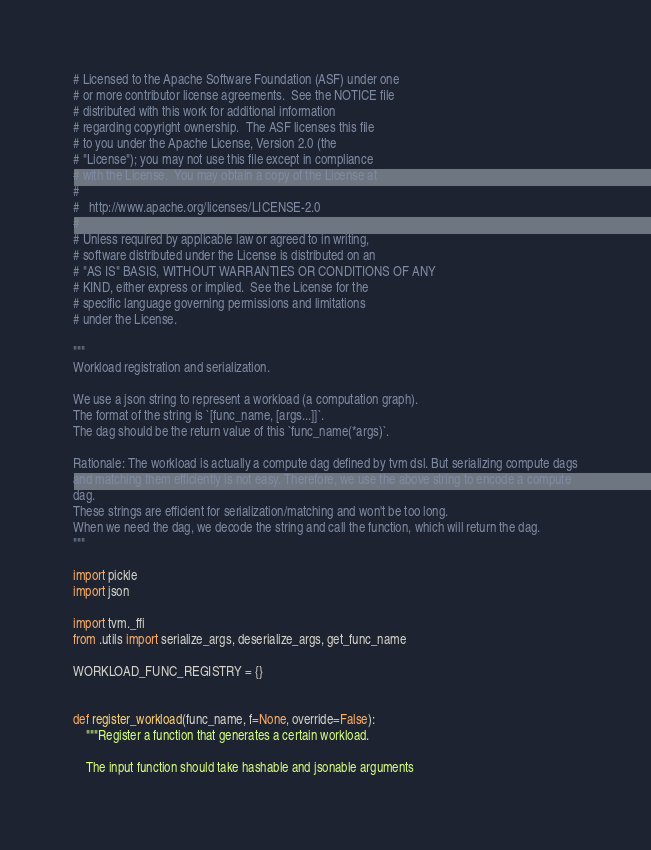Convert code to text. <code><loc_0><loc_0><loc_500><loc_500><_Python_># Licensed to the Apache Software Foundation (ASF) under one
# or more contributor license agreements.  See the NOTICE file
# distributed with this work for additional information
# regarding copyright ownership.  The ASF licenses this file
# to you under the Apache License, Version 2.0 (the
# "License"); you may not use this file except in compliance
# with the License.  You may obtain a copy of the License at
#
#   http://www.apache.org/licenses/LICENSE-2.0
#
# Unless required by applicable law or agreed to in writing,
# software distributed under the License is distributed on an
# "AS IS" BASIS, WITHOUT WARRANTIES OR CONDITIONS OF ANY
# KIND, either express or implied.  See the License for the
# specific language governing permissions and limitations
# under the License.

"""
Workload registration and serialization.

We use a json string to represent a workload (a computation graph).
The format of the string is `[func_name, [args...]]`.
The dag should be the return value of this `func_name(*args)`.

Rationale: The workload is actually a compute dag defined by tvm dsl. But serializing compute dags
and matching them efficiently is not easy. Therefore, we use the above string to encode a compute
dag.
These strings are efficient for serialization/matching and won't be too long.
When we need the dag, we decode the string and call the function, which will return the dag.
"""

import pickle
import json

import tvm._ffi
from .utils import serialize_args, deserialize_args, get_func_name

WORKLOAD_FUNC_REGISTRY = {}


def register_workload(func_name, f=None, override=False):
    """Register a function that generates a certain workload.

    The input function should take hashable and jsonable arguments</code> 